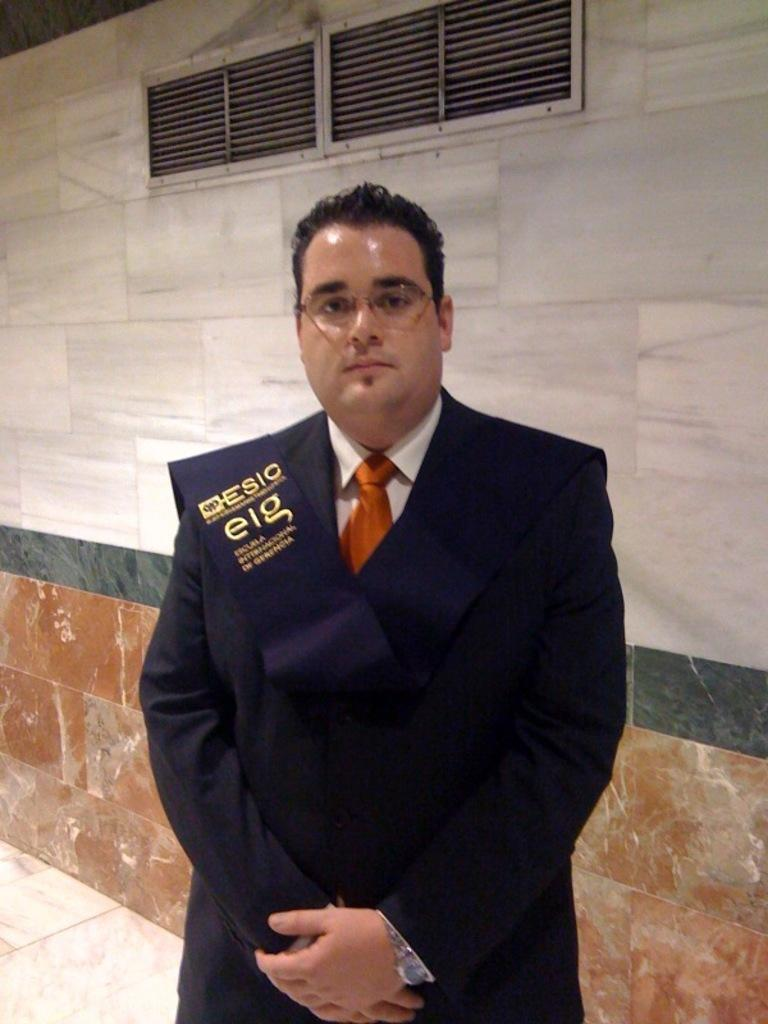What is the main subject in the foreground of the image? There is a man standing in the foreground of the image. What can be seen in the background of the image? There is a wall in the background of the image. Can you describe any specific features of the wall? There is an air conditioner visible at the top of the wall in the background. How many straws are being used by the rabbits in the image? There are no rabbits or straws present in the image. 